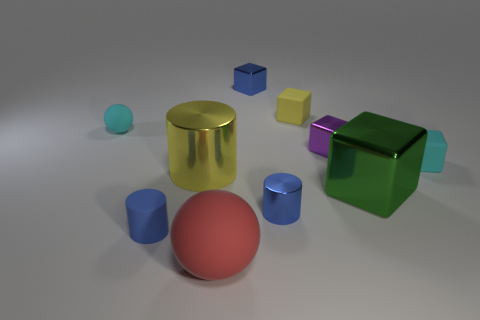Subtract all large cylinders. How many cylinders are left? 2 Subtract all purple balls. How many blue cylinders are left? 2 Subtract 4 cubes. How many cubes are left? 1 Subtract all blue blocks. How many blocks are left? 4 Subtract all cylinders. How many objects are left? 7 Add 9 yellow rubber cubes. How many yellow rubber cubes are left? 10 Add 3 big yellow cylinders. How many big yellow cylinders exist? 4 Subtract 1 green blocks. How many objects are left? 9 Subtract all brown balls. Subtract all gray blocks. How many balls are left? 2 Subtract all cyan cubes. Subtract all small blue blocks. How many objects are left? 8 